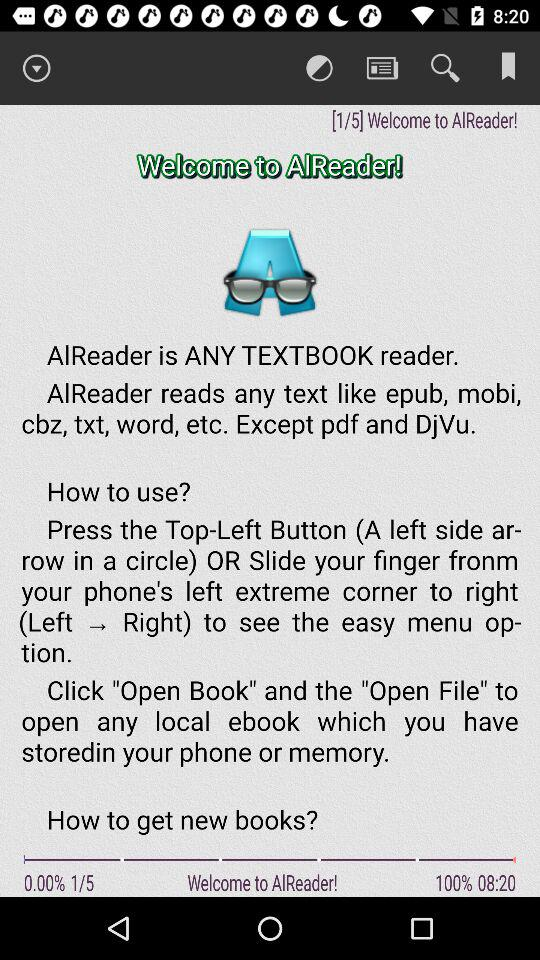Which page number are we currently on? You are currently on page number 1. 